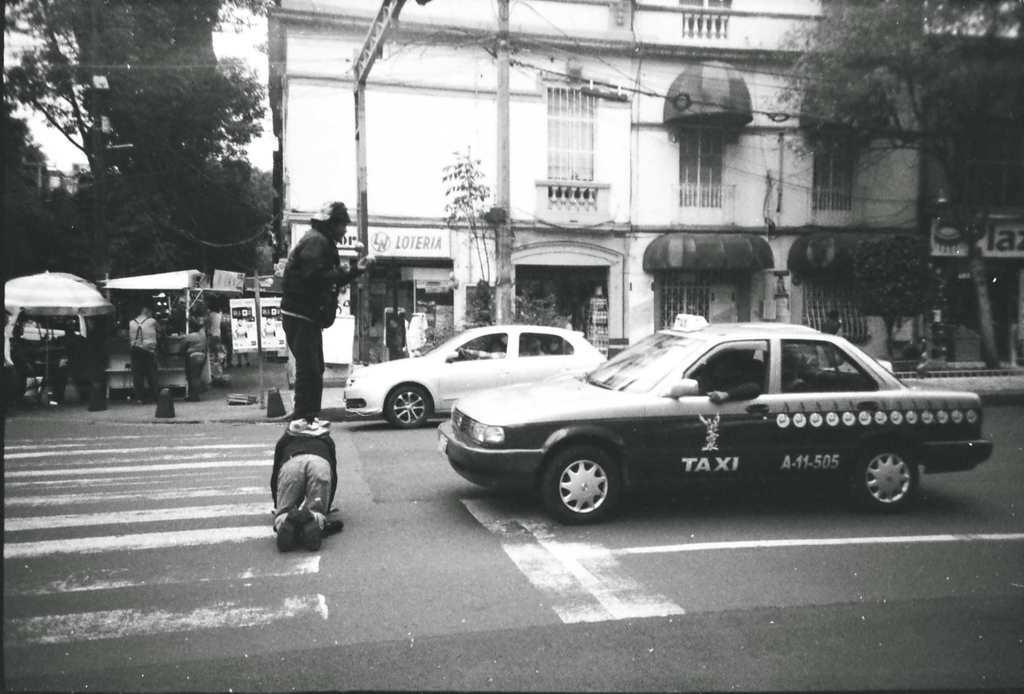<image>
Describe the image concisely. A man standing infront of a taxi number A-11-505 